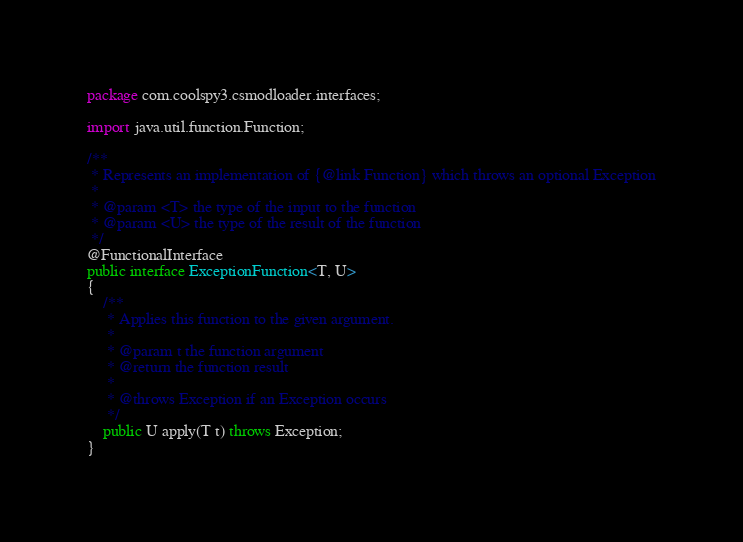<code> <loc_0><loc_0><loc_500><loc_500><_Java_>package com.coolspy3.csmodloader.interfaces;

import java.util.function.Function;

/**
 * Represents an implementation of {@link Function} which throws an optional Exception
 *
 * @param <T> the type of the input to the function
 * @param <U> the type of the result of the function
 */
@FunctionalInterface
public interface ExceptionFunction<T, U>
{
    /**
     * Applies this function to the given argument.
     *
     * @param t the function argument
     * @return the function result
     *
     * @throws Exception if an Exception occurs
     */
    public U apply(T t) throws Exception;
}
</code> 